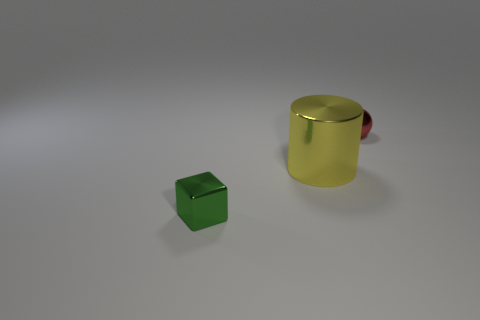Add 3 brown rubber cylinders. How many objects exist? 6 Subtract all cylinders. How many objects are left? 2 Subtract all gray things. Subtract all red balls. How many objects are left? 2 Add 1 small cubes. How many small cubes are left? 2 Add 3 big metallic cylinders. How many big metallic cylinders exist? 4 Subtract 0 cyan cubes. How many objects are left? 3 